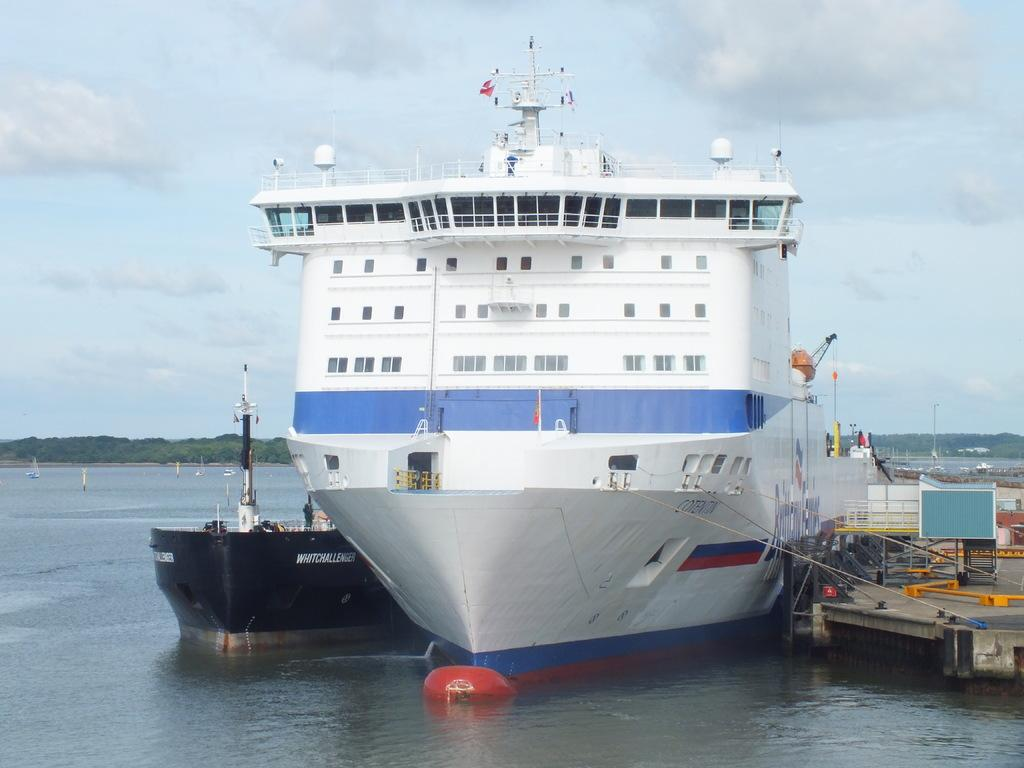What is the main subject in the center of the image? There are ships in the center of the image. What can be seen in the background of the image? There are trees in the background of the image. What is the primary feature of the landscape in the image? There is water visible in the image. How would you describe the weather in the image? The sky is cloudy in the image. What is the desire of the thunder in the image? There is no thunder present in the image, so it is not possible to determine its desires. 